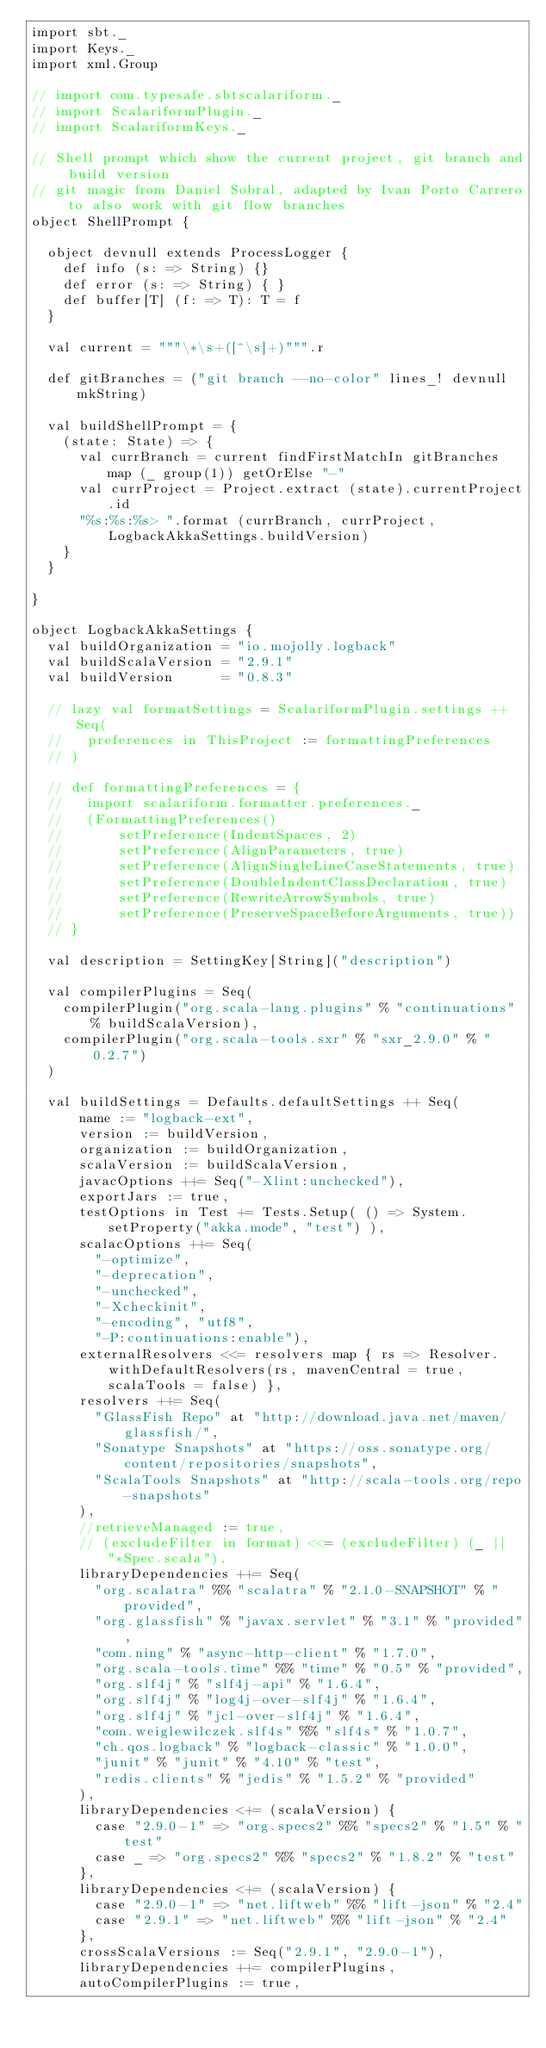Convert code to text. <code><loc_0><loc_0><loc_500><loc_500><_Scala_>import sbt._
import Keys._
import xml.Group

// import com.typesafe.sbtscalariform._
// import ScalariformPlugin._
// import ScalariformKeys._

// Shell prompt which show the current project, git branch and build version
// git magic from Daniel Sobral, adapted by Ivan Porto Carrero to also work with git flow branches
object ShellPrompt {
 
  object devnull extends ProcessLogger {
    def info (s: => String) {}
    def error (s: => String) { }
    def buffer[T] (f: => T): T = f
  }
  
  val current = """\*\s+([^\s]+)""".r
  
  def gitBranches = ("git branch --no-color" lines_! devnull mkString)
  
  val buildShellPrompt = { 
    (state: State) => {
      val currBranch = current findFirstMatchIn gitBranches map (_ group(1)) getOrElse "-"
      val currProject = Project.extract (state).currentProject.id
      "%s:%s:%s> ".format (currBranch, currProject, LogbackAkkaSettings.buildVersion)
    }
  }
 
}

object LogbackAkkaSettings {
  val buildOrganization = "io.mojolly.logback"
  val buildScalaVersion = "2.9.1"
  val buildVersion      = "0.8.3"

  // lazy val formatSettings = ScalariformPlugin.settings ++ Seq(
  //   preferences in ThisProject := formattingPreferences
  // )

  // def formattingPreferences = {
  //   import scalariform.formatter.preferences._
  //   (FormattingPreferences()
  //       setPreference(IndentSpaces, 2)
  //       setPreference(AlignParameters, true)
  //       setPreference(AlignSingleLineCaseStatements, true)
  //       setPreference(DoubleIndentClassDeclaration, true)
  //       setPreference(RewriteArrowSymbols, true)
  //       setPreference(PreserveSpaceBeforeArguments, true))
  // }

  val description = SettingKey[String]("description")

  val compilerPlugins = Seq(
    compilerPlugin("org.scala-lang.plugins" % "continuations" % buildScalaVersion),
    compilerPlugin("org.scala-tools.sxr" % "sxr_2.9.0" % "0.2.7")
  )

  val buildSettings = Defaults.defaultSettings ++ Seq(
      name := "logback-ext",
      version := buildVersion,
      organization := buildOrganization,
      scalaVersion := buildScalaVersion,
      javacOptions ++= Seq("-Xlint:unchecked"),
      exportJars := true,
      testOptions in Test += Tests.Setup( () => System.setProperty("akka.mode", "test") ),
      scalacOptions ++= Seq(
        "-optimize",
        "-deprecation",
        "-unchecked",
        "-Xcheckinit",
        "-encoding", "utf8",
        "-P:continuations:enable"),
      externalResolvers <<= resolvers map { rs => Resolver.withDefaultResolvers(rs, mavenCentral = true, scalaTools = false) },
      resolvers ++= Seq(
        "GlassFish Repo" at "http://download.java.net/maven/glassfish/",
        "Sonatype Snapshots" at "https://oss.sonatype.org/content/repositories/snapshots",
        "ScalaTools Snapshots" at "http://scala-tools.org/repo-snapshots"
      ),
      //retrieveManaged := true,
      // (excludeFilter in format) <<= (excludeFilter) (_ || "*Spec.scala"),
      libraryDependencies ++= Seq(
        "org.scalatra" %% "scalatra" % "2.1.0-SNAPSHOT" % "provided",
        "org.glassfish" % "javax.servlet" % "3.1" % "provided",
        "com.ning" % "async-http-client" % "1.7.0",
        "org.scala-tools.time" %% "time" % "0.5" % "provided",
        "org.slf4j" % "slf4j-api" % "1.6.4",
        "org.slf4j" % "log4j-over-slf4j" % "1.6.4",
        "org.slf4j" % "jcl-over-slf4j" % "1.6.4",
        "com.weiglewilczek.slf4s" %% "slf4s" % "1.0.7",
        "ch.qos.logback" % "logback-classic" % "1.0.0",
        "junit" % "junit" % "4.10" % "test",
        "redis.clients" % "jedis" % "1.5.2" % "provided"
      ),
      libraryDependencies <+= (scalaVersion) {
        case "2.9.0-1" => "org.specs2" %% "specs2" % "1.5" % "test"
        case _ => "org.specs2" %% "specs2" % "1.8.2" % "test"
      },
      libraryDependencies <+= (scalaVersion) {
        case "2.9.0-1" => "net.liftweb" %% "lift-json" % "2.4"
        case "2.9.1" => "net.liftweb" %% "lift-json" % "2.4"
      },
      crossScalaVersions := Seq("2.9.1", "2.9.0-1"),
      libraryDependencies ++= compilerPlugins,
      autoCompilerPlugins := true,</code> 